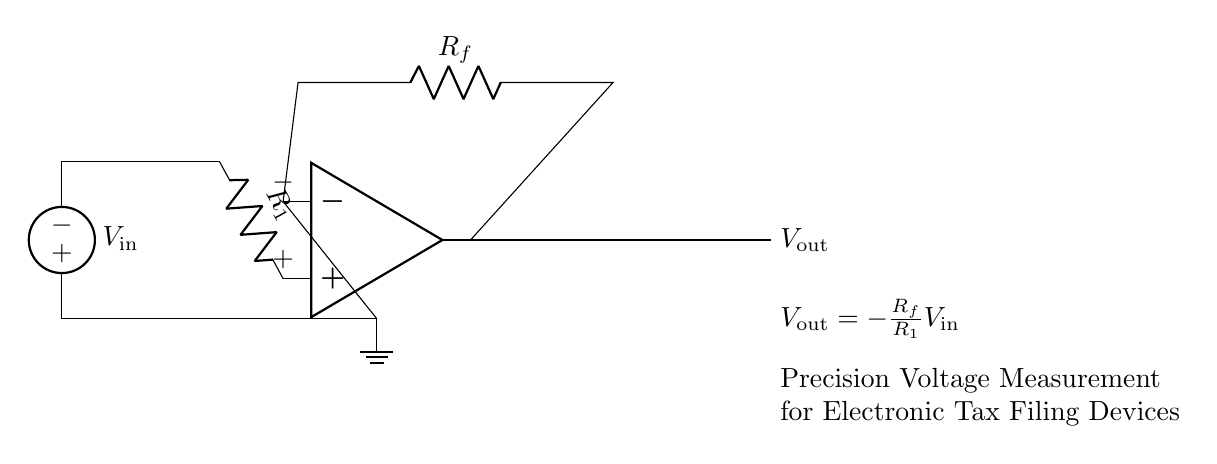What is the input voltage in the circuit? The input voltage is represented as V_in, which is connected to the positive terminal of the operational amplifier designated as the inverting input.
Answer: V_in What type of components are R_1 and R_f? R_1 and R_f are resistors, which are indicated in the circuit diagram and are responsible for setting the gain of the operational amplifier.
Answer: Resistors What is the output voltage equation for this circuit? The output voltage equation is given in the circuit diagram as V_out = -R_f/R_1 * V_in, describing how the output relates to the input and the resistors.
Answer: V_out = -R_f/R_1 * V_in What is the role of the operational amplifier in this circuit? The operational amplifier functions as a voltage amplifier, amplifying the difference between its inverting and non-inverting inputs to produce V_out.
Answer: Voltage amplifier If R_1 is 1 kOhm and R_f is 10 kOhm, what is the gain of the amplifier? The gain is calculated using the equation Gain = -R_f/R_1, substituting the given values results in Gain = -10. Therefore, the output will be inverted and amplified by a factor of ten.
Answer: -10 Which terminal of the operational amplifier is the non-inverting input? The non-inverting input is indicated by the plus sign (+) located at the top side of the operational amplifier symbol in the circuit.
Answer: Plus sign (+) What does the ground connection signify in this circuit? The ground connection indicates a common reference point for all voltages in the circuit, serving as the zero voltage level for the input and output measurements.
Answer: Zero voltage level 